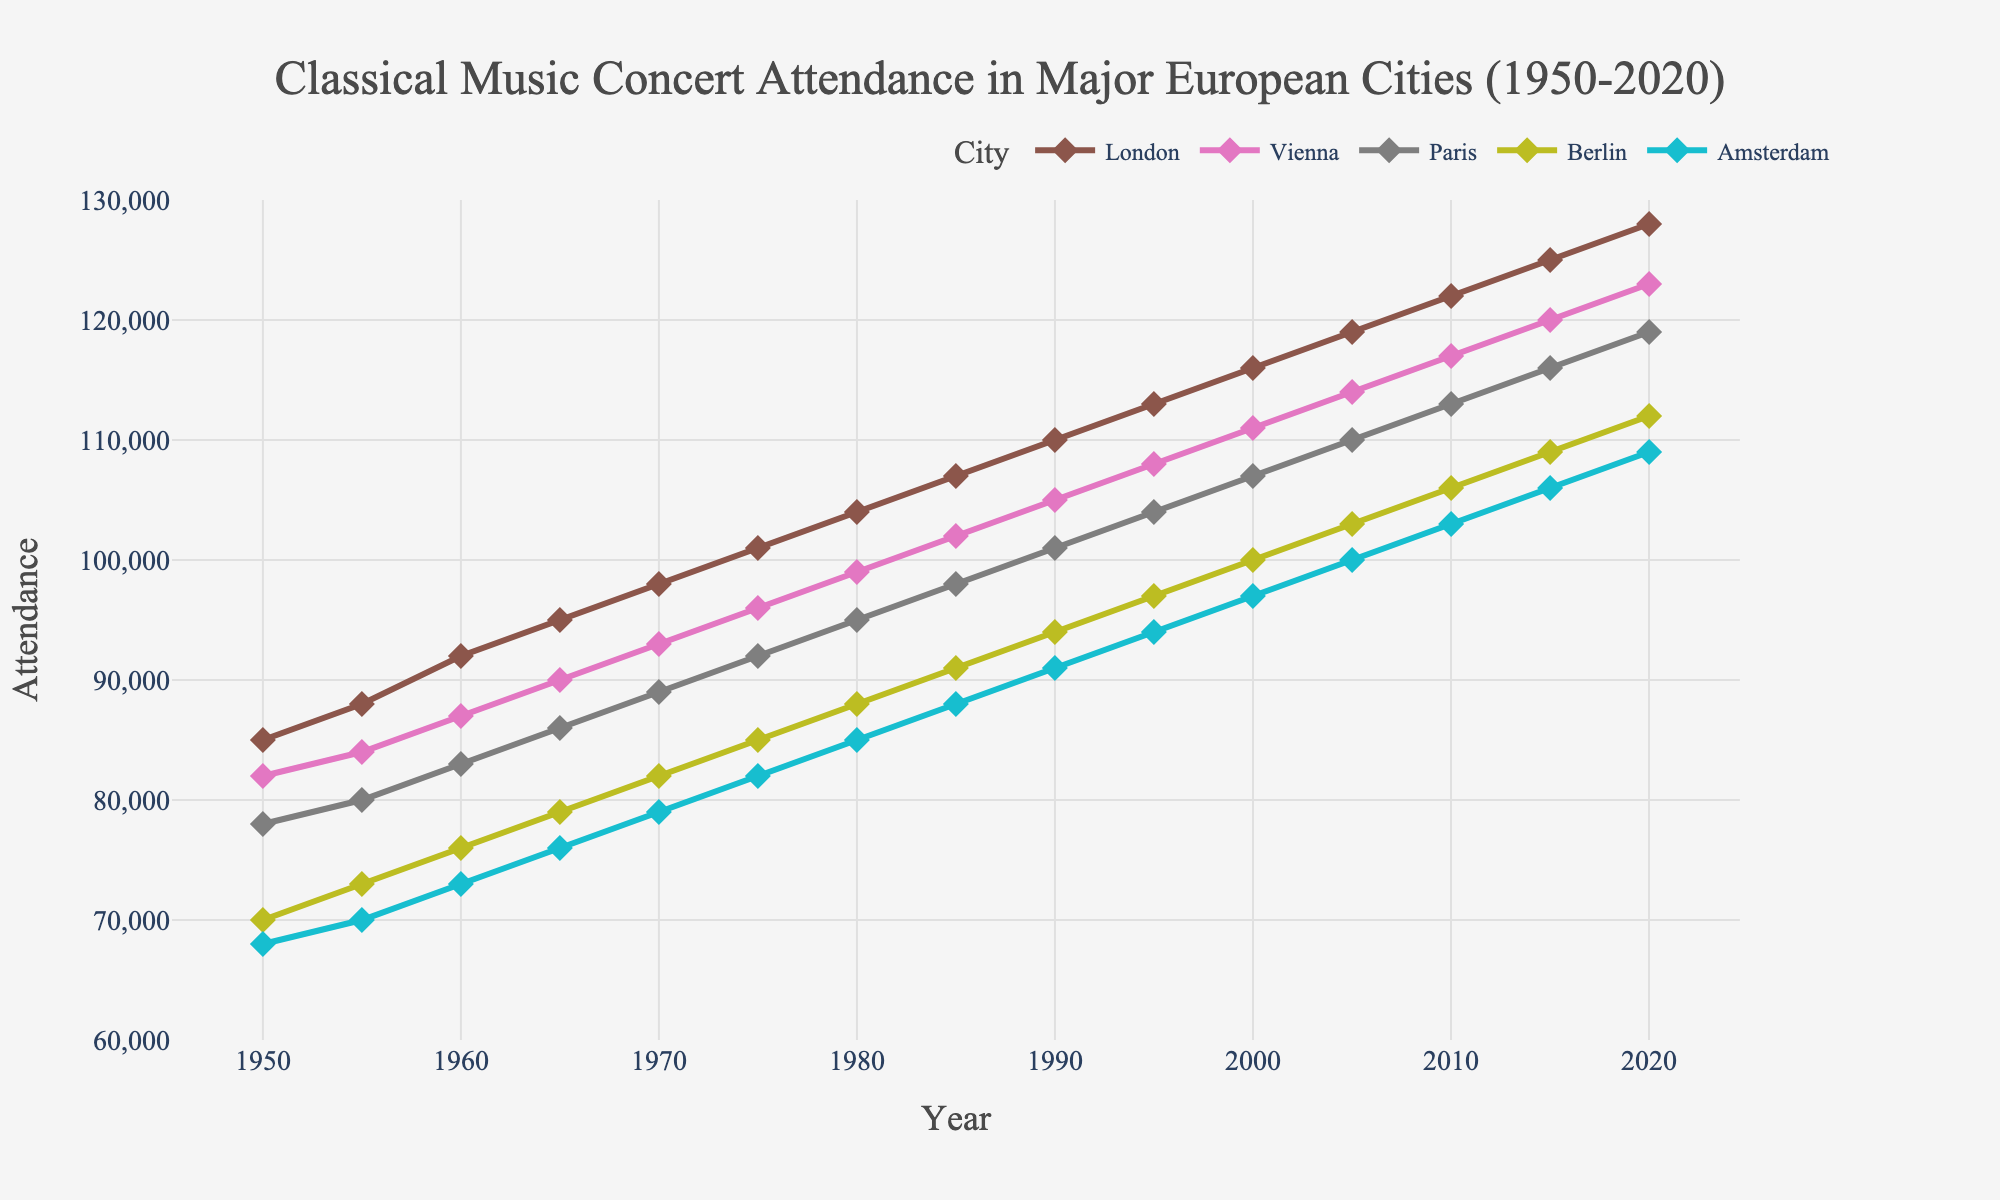What is the trend in concert attendance in London from 1950 to 2020? The plot shows the attendance in London increasing from 85,000 in 1950 to 128,000 in 2020, demonstrating a consistent upward trend.
Answer: Upward trend Which city had the highest concert attendance in 1955? In 1955, the attendance values are as follows: London (88,000), Vienna (84,000), Paris (80,000), Berlin (73,000), Amsterdam (70,000). Therefore, London had the highest attendance.
Answer: London How does the increase in concert attendance in Paris from 1970 to 1990 compare to the increase in Berlin during the same period? Paris' attendance increased from 89,000 in 1970 to 101,000 in 1990, a total increase of 12,000. Berlin's attendance increased from 82,000 in 1970 to 94,000 in 1990, amounting to an increase of 12,000 as well. Both cities saw the same increase.
Answer: Same increase What was the approximate average attendance across all cities in 1980? The attendance in 1980 for each city is: London (104,000), Vienna (99,000), Paris (95,000), Berlin (88,000), Amsterdam (85,000). The average is (104,000 + 99,000 + 95,000 + 88,000 + 85,000) / 5 = 471,000 / 5 = 94,200.
Answer: 94,200 Between which years did Vienna see the largest increase in concert attendance? The largest increase in Vienna’s attendance occurred between 2015 and 2020, rising from 120,000 to 123,000, an increase of 3,000, which is greater than any other five-year period shown in the plot.
Answer: 2015 to 2020 How much did the concert attendance in Amsterdam change from 1950 to 2020? The attendance increased from 68,000 in 1950 to 109,000 in 2020. The change is 109,000 - 68,000 = 41,000.
Answer: 41,000 In which city did the concert attendance reach 100,000 first, and in which year? According to the plot, London reached an attendance of 100,000 first in 1975.
Answer: London (1975) Which city had the least fluctuation in concert attendance throughout the period? Amsterdam shows the smallest fluctuation with a relatively steady increase, starting at 68,000 in 1950 and ending at 109,000 in 2020, with no significant spikes.
Answer: Amsterdam How does the trend in Paris compare to that in Vienna over the years? Both Paris and Vienna show a similar upward trend from 1950 to 2020. While Paris consistently follows Vienna, it remains slightly lower in attendance numbers throughout the period.
Answer: Similar but consistently lower In 2000, which city had concert attendance closest to the average attendance across all cities? The attendance values for 2000 are: London (116,000), Vienna (111,000), Paris (107,000), Berlin (100,000), Amsterdam (97,000). The average is (116,000 + 111,000 + 107,000 + 100,000 + 97,000) / 5 = 531,000 / 5 = 106,200. Paris, with 107,000, is closest to this average.
Answer: Paris 